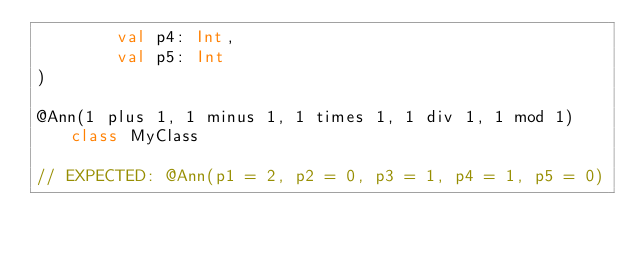Convert code to text. <code><loc_0><loc_0><loc_500><loc_500><_Kotlin_>        val p4: Int,
        val p5: Int
)

@Ann(1 plus 1, 1 minus 1, 1 times 1, 1 div 1, 1 mod 1) class MyClass

// EXPECTED: @Ann(p1 = 2, p2 = 0, p3 = 1, p4 = 1, p5 = 0)
</code> 